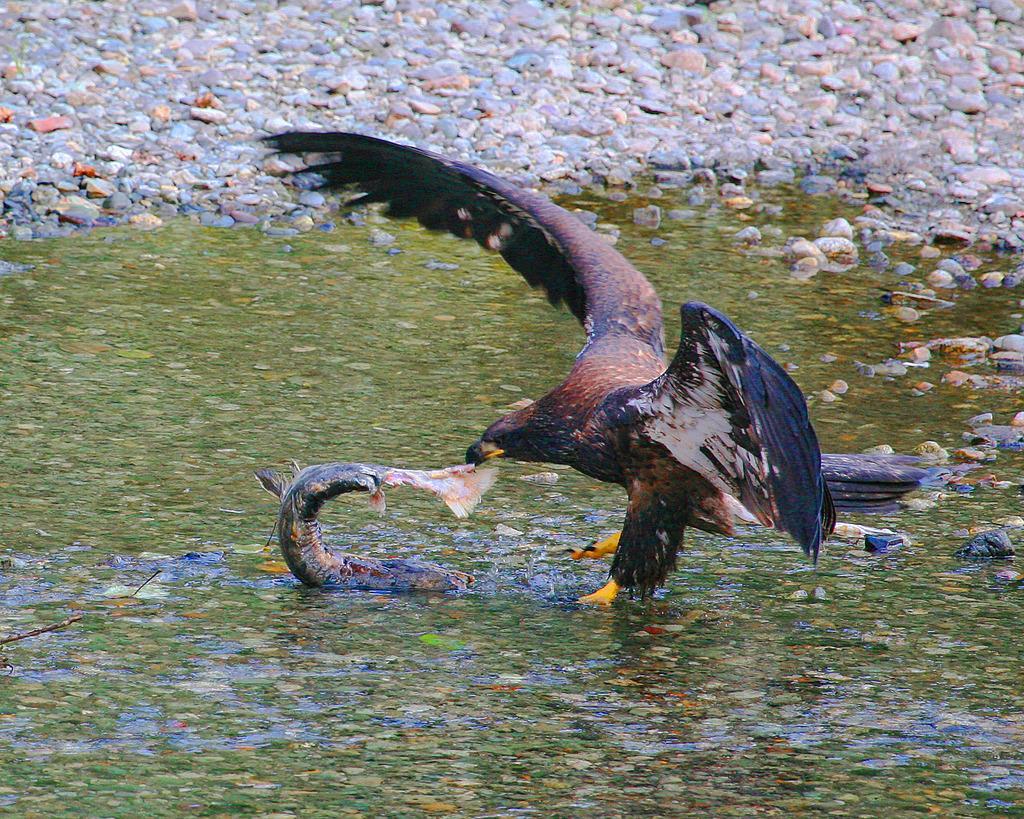How would you summarize this image in a sentence or two? There is an eagle and a fish present on the surface of water as we can see in the middle of this image, and there are some stones in the background. 